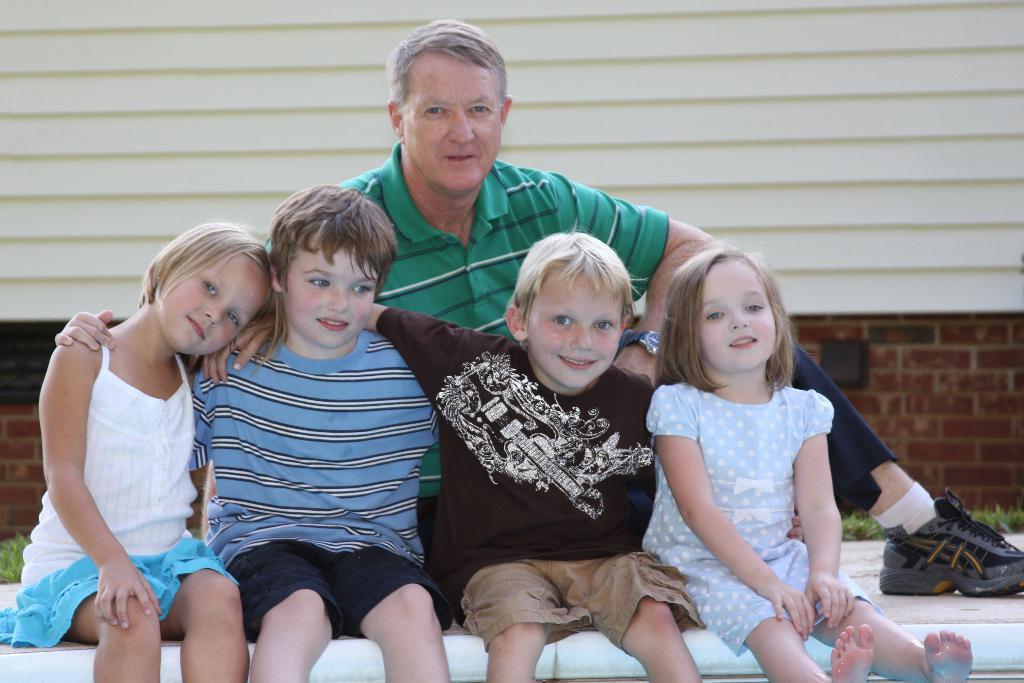Could you give a brief overview of what you see in this image? This image consists of five persons. In the front, we can see four children sitting. In the background, there is a man wearing a green T-shirt is sitting. And we can see a wall along with green grass. 